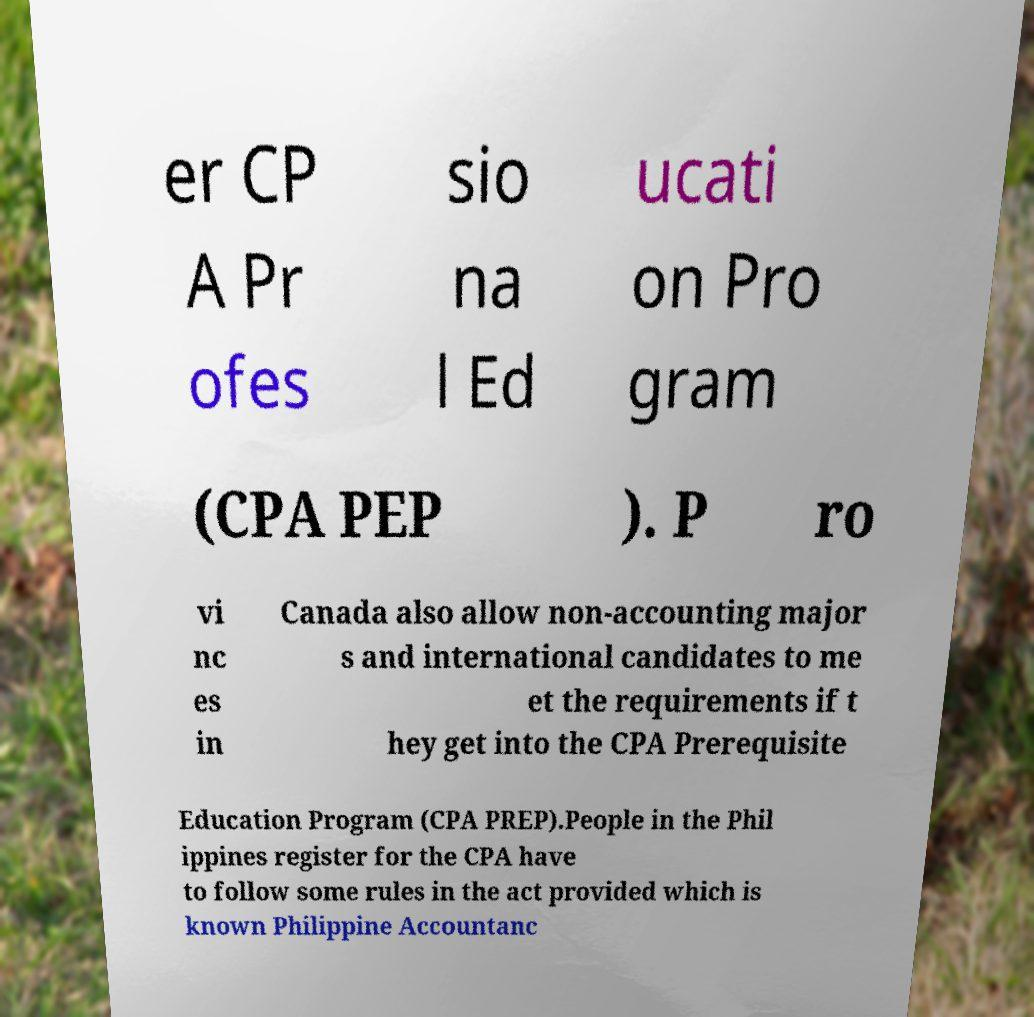I need the written content from this picture converted into text. Can you do that? er CP A Pr ofes sio na l Ed ucati on Pro gram (CPA PEP ). P ro vi nc es in Canada also allow non-accounting major s and international candidates to me et the requirements if t hey get into the CPA Prerequisite Education Program (CPA PREP).People in the Phil ippines register for the CPA have to follow some rules in the act provided which is known Philippine Accountanc 